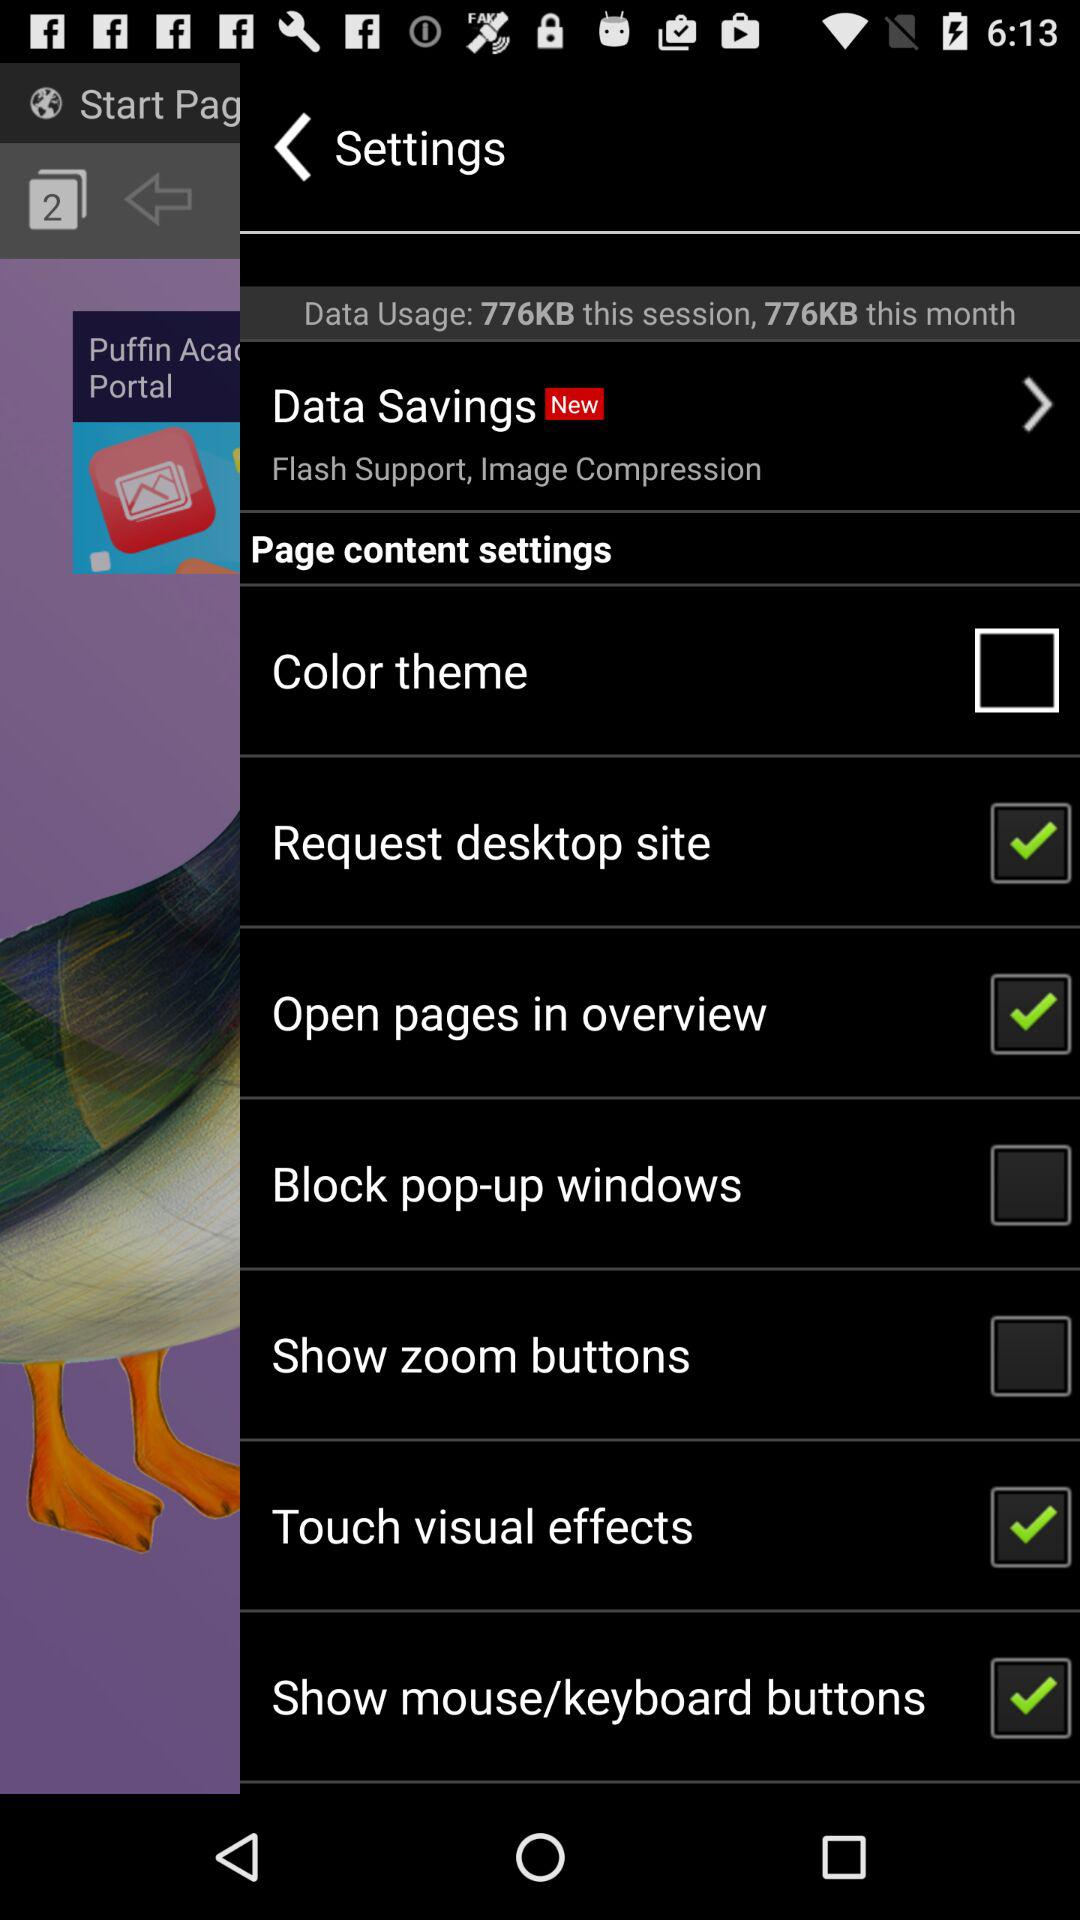Is "Page content settings" selected or not?
When the provided information is insufficient, respond with <no answer>. <no answer> 